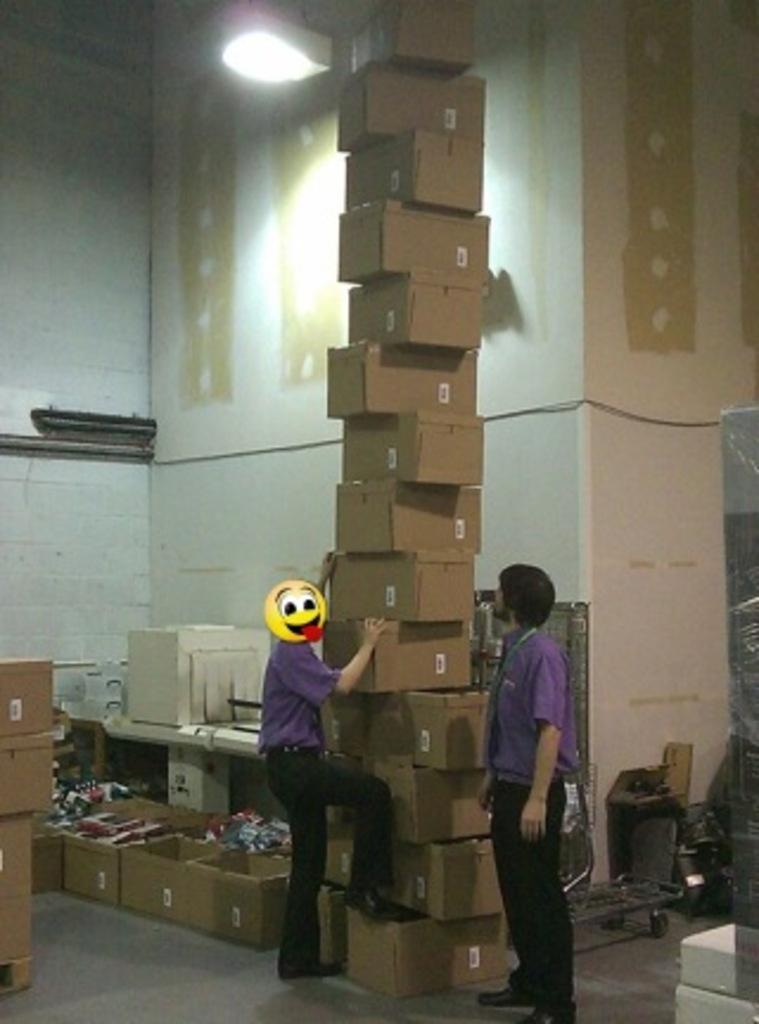In one or two sentences, can you explain what this image depicts? In this image there are two people, few boxes in which there are few objects in some of the boxes, few objects on the table, a trolley, a light hanging from the roof and some objects are in the room. 